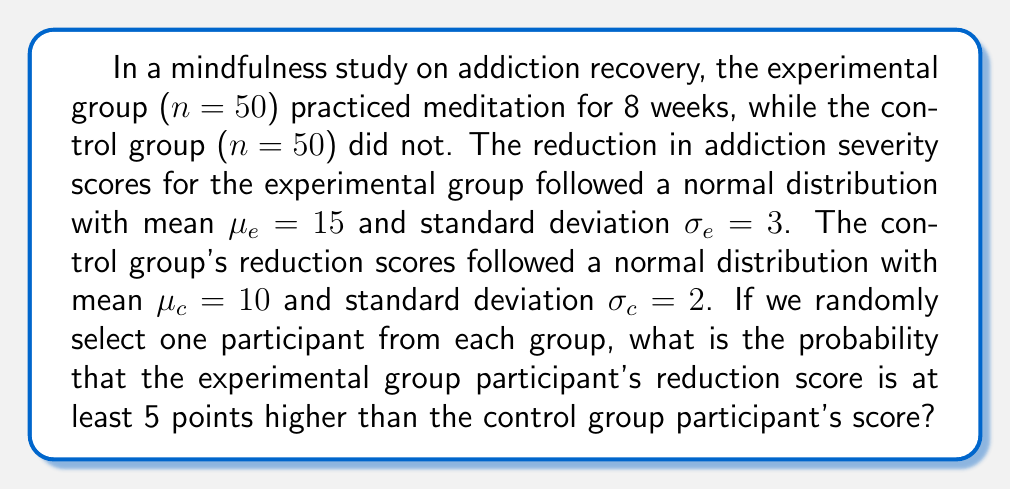Could you help me with this problem? Let's approach this step-by-step:

1) Let $X_e$ be the reduction score for a randomly selected participant from the experimental group, and $X_c$ be the reduction score for a randomly selected participant from the control group.

2) We need to find $P(X_e - X_c \geq 5)$

3) We know that $X_e \sim N(15, 3^2)$ and $X_c \sim N(10, 2^2)$

4) The difference between two normally distributed variables is also normally distributed. Let $Y = X_e - X_c$

5) The mean of Y is: $\mu_Y = \mu_e - \mu_c = 15 - 10 = 5$

6) The variance of Y is the sum of the variances: $\sigma_Y^2 = \sigma_e^2 + \sigma_c^2 = 3^2 + 2^2 = 9 + 4 = 13$

7) So, $Y \sim N(5, \sqrt{13})$

8) We want to find $P(Y \geq 5)$

9) Standardizing this:
   $Z = \frac{Y - \mu_Y}{\sigma_Y} = \frac{5 - 5}{\sqrt{13}} = 0$

10) Therefore, we need to find $P(Z \geq 0)$

11) From the standard normal distribution table, we know that $P(Z \geq 0) = 0.5$

Therefore, the probability that the experimental group participant's reduction score is at least 5 points higher than the control group participant's score is 0.5 or 50%.
Answer: 0.5 